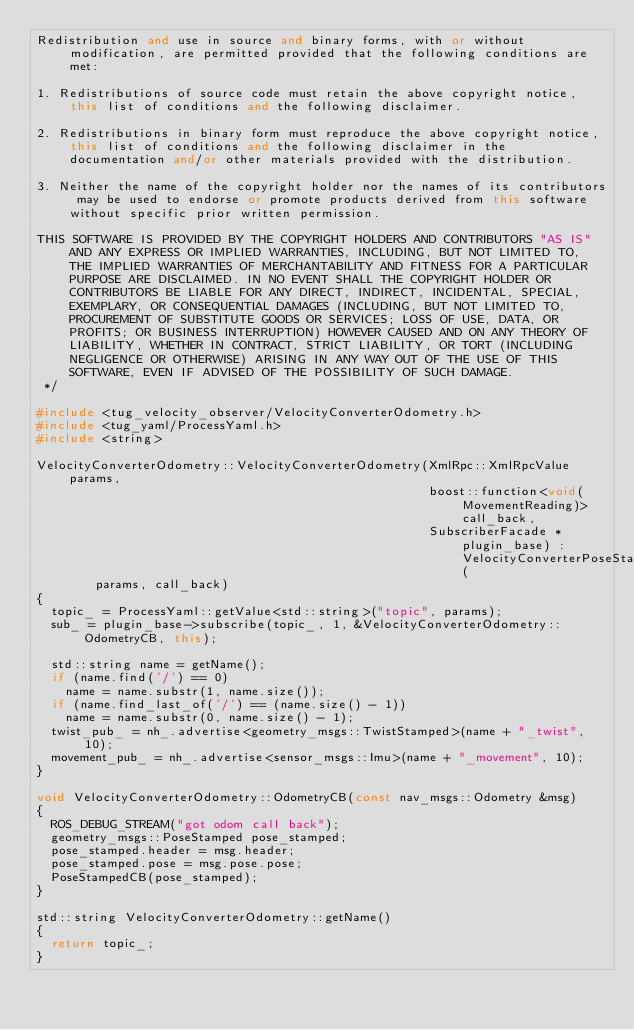Convert code to text. <code><loc_0><loc_0><loc_500><loc_500><_C++_>Redistribution and use in source and binary forms, with or without modification, are permitted provided that the following conditions are met:

1. Redistributions of source code must retain the above copyright notice, this list of conditions and the following disclaimer.

2. Redistributions in binary form must reproduce the above copyright notice, this list of conditions and the following disclaimer in the documentation and/or other materials provided with the distribution.

3. Neither the name of the copyright holder nor the names of its contributors may be used to endorse or promote products derived from this software without specific prior written permission.

THIS SOFTWARE IS PROVIDED BY THE COPYRIGHT HOLDERS AND CONTRIBUTORS "AS IS" AND ANY EXPRESS OR IMPLIED WARRANTIES, INCLUDING, BUT NOT LIMITED TO, THE IMPLIED WARRANTIES OF MERCHANTABILITY AND FITNESS FOR A PARTICULAR PURPOSE ARE DISCLAIMED. IN NO EVENT SHALL THE COPYRIGHT HOLDER OR CONTRIBUTORS BE LIABLE FOR ANY DIRECT, INDIRECT, INCIDENTAL, SPECIAL, EXEMPLARY, OR CONSEQUENTIAL DAMAGES (INCLUDING, BUT NOT LIMITED TO, PROCUREMENT OF SUBSTITUTE GOODS OR SERVICES; LOSS OF USE, DATA, OR PROFITS; OR BUSINESS INTERRUPTION) HOWEVER CAUSED AND ON ANY THEORY OF LIABILITY, WHETHER IN CONTRACT, STRICT LIABILITY, OR TORT (INCLUDING NEGLIGENCE OR OTHERWISE) ARISING IN ANY WAY OUT OF THE USE OF THIS SOFTWARE, EVEN IF ADVISED OF THE POSSIBILITY OF SUCH DAMAGE.
 */

#include <tug_velocity_observer/VelocityConverterOdometry.h>
#include <tug_yaml/ProcessYaml.h>
#include <string>

VelocityConverterOdometry::VelocityConverterOdometry(XmlRpc::XmlRpcValue params,
                                                     boost::function<void(MovementReading)> call_back,
                                                     SubscriberFacade *plugin_base) : VelocityConverterPoseStamped(
        params, call_back)
{
  topic_ = ProcessYaml::getValue<std::string>("topic", params);
  sub_ = plugin_base->subscribe(topic_, 1, &VelocityConverterOdometry::OdometryCB, this);

  std::string name = getName();
  if (name.find('/') == 0)
    name = name.substr(1, name.size());
  if (name.find_last_of('/') == (name.size() - 1))
    name = name.substr(0, name.size() - 1);
  twist_pub_ = nh_.advertise<geometry_msgs::TwistStamped>(name + "_twist", 10);
  movement_pub_ = nh_.advertise<sensor_msgs::Imu>(name + "_movement", 10);
}

void VelocityConverterOdometry::OdometryCB(const nav_msgs::Odometry &msg)
{
  ROS_DEBUG_STREAM("got odom call back");
  geometry_msgs::PoseStamped pose_stamped;
  pose_stamped.header = msg.header;
  pose_stamped.pose = msg.pose.pose;
  PoseStampedCB(pose_stamped);
}

std::string VelocityConverterOdometry::getName()
{
  return topic_;
}
</code> 